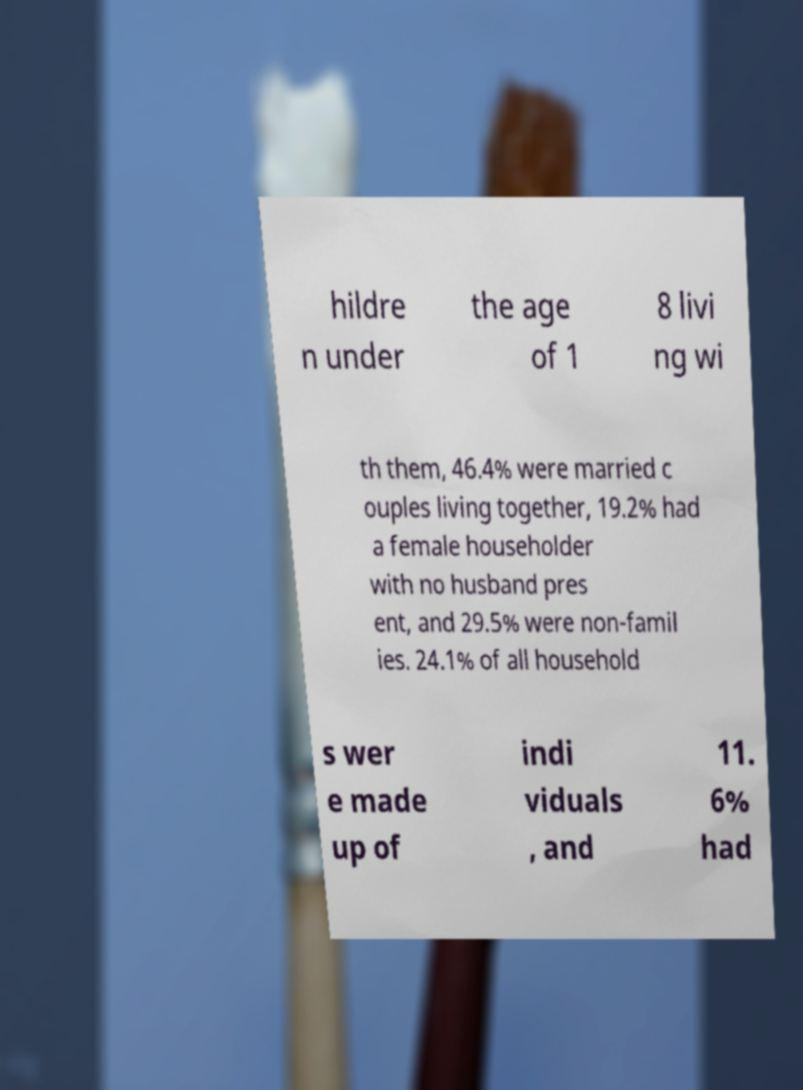There's text embedded in this image that I need extracted. Can you transcribe it verbatim? hildre n under the age of 1 8 livi ng wi th them, 46.4% were married c ouples living together, 19.2% had a female householder with no husband pres ent, and 29.5% were non-famil ies. 24.1% of all household s wer e made up of indi viduals , and 11. 6% had 